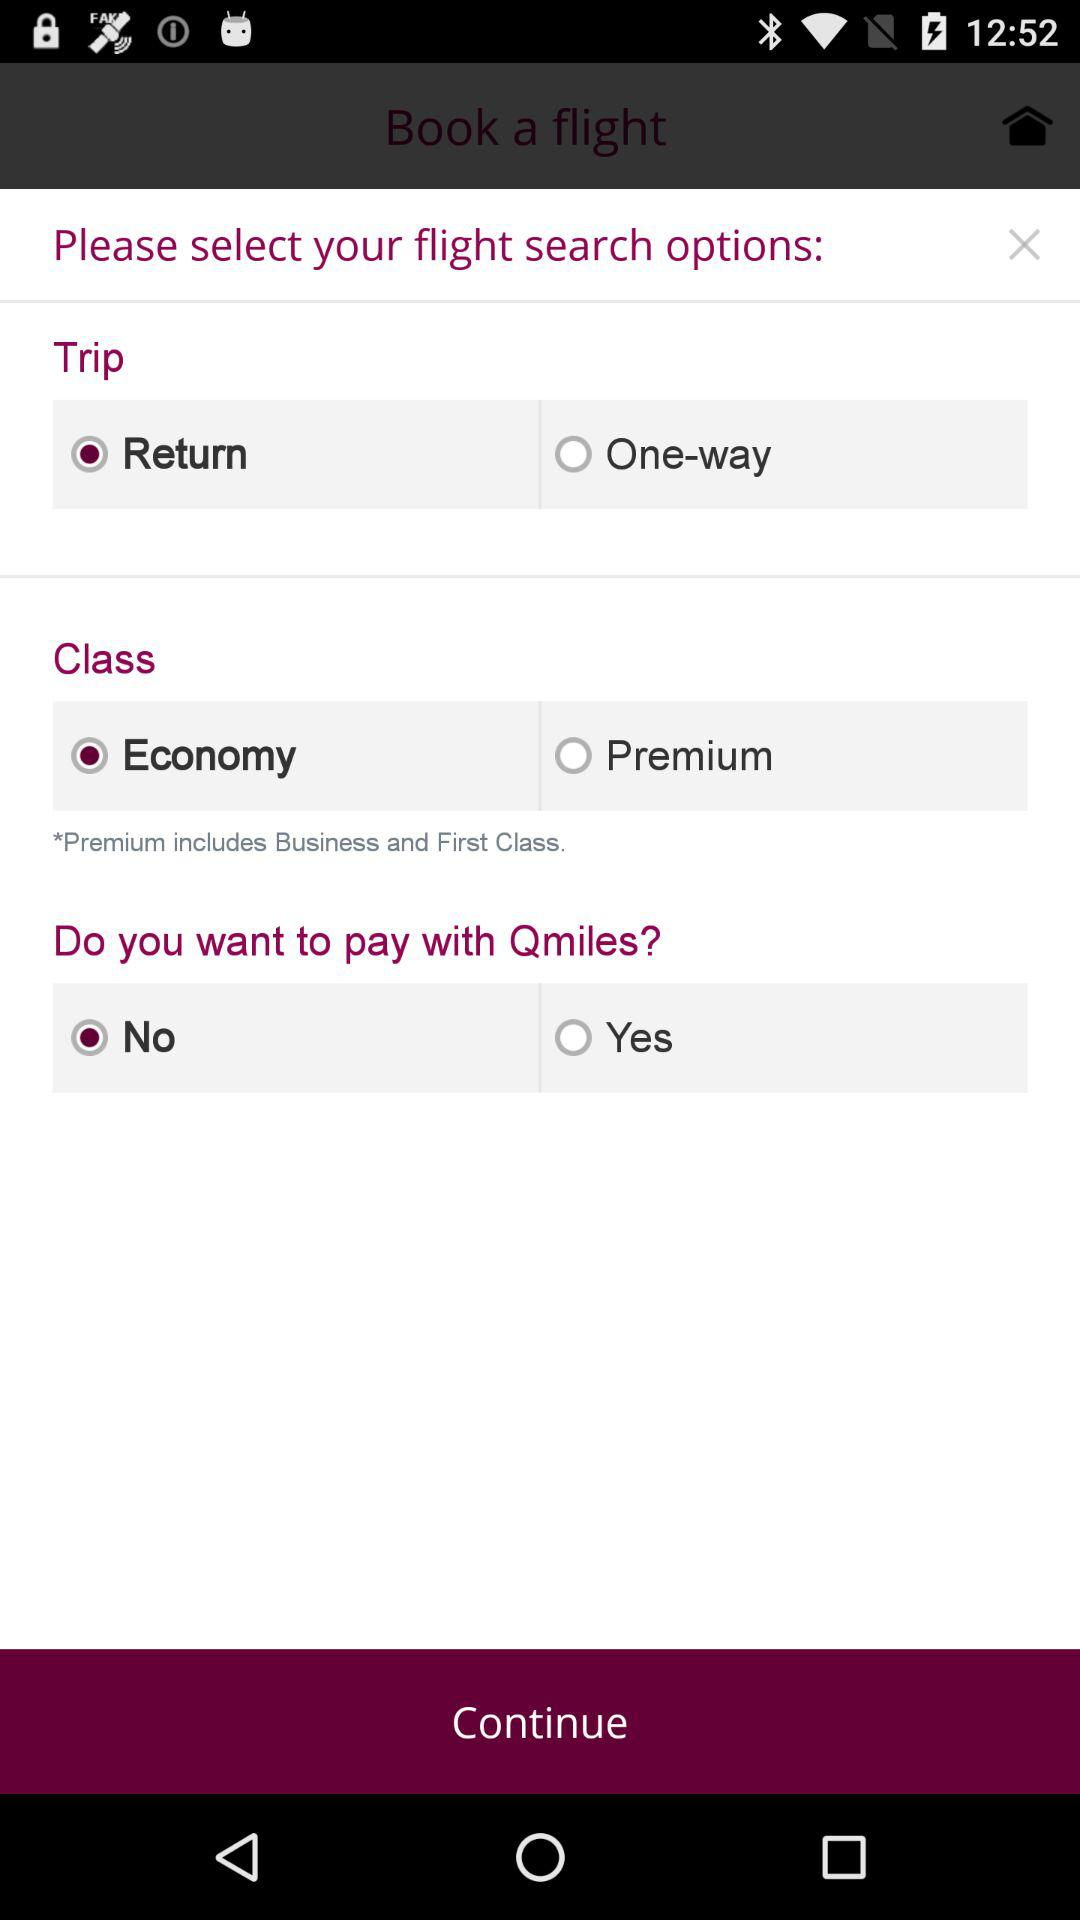Which option is checked?
When the provided information is insufficient, respond with <no answer>. <no answer> 